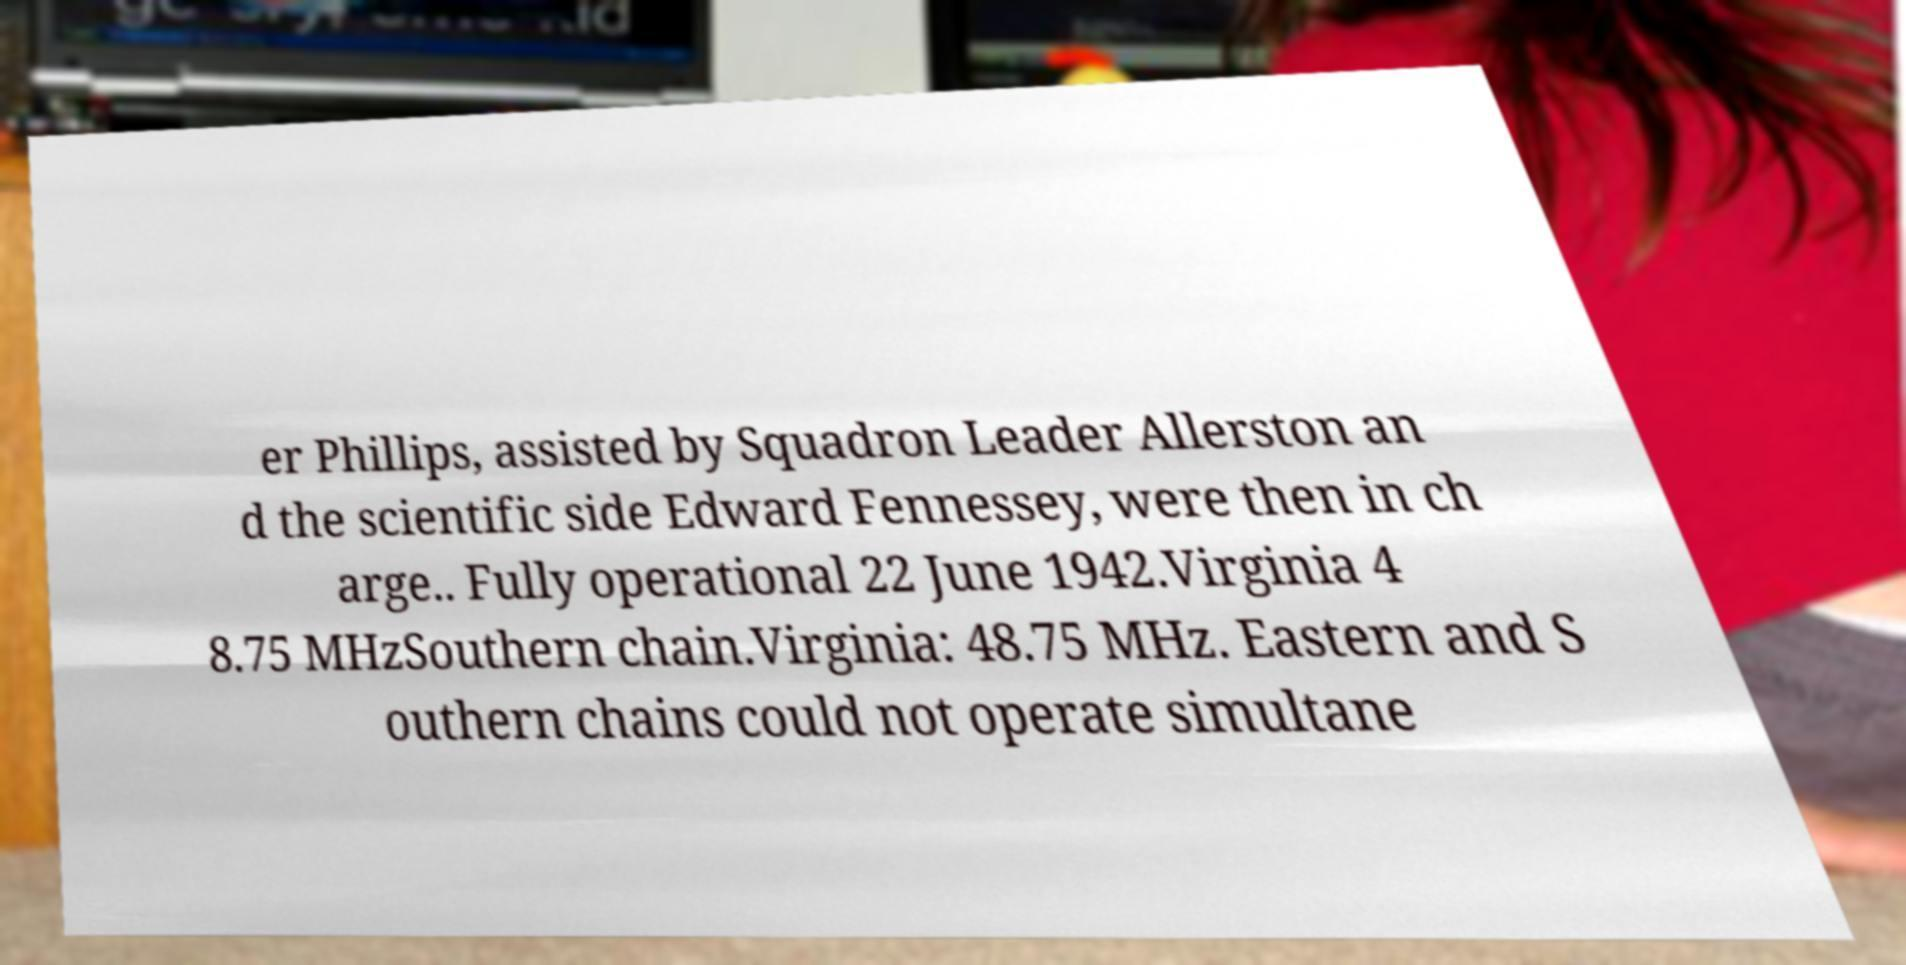Can you read and provide the text displayed in the image?This photo seems to have some interesting text. Can you extract and type it out for me? er Phillips, assisted by Squadron Leader Allerston an d the scientific side Edward Fennessey, were then in ch arge.. Fully operational 22 June 1942.Virginia 4 8.75 MHzSouthern chain.Virginia: 48.75 MHz. Eastern and S outhern chains could not operate simultane 